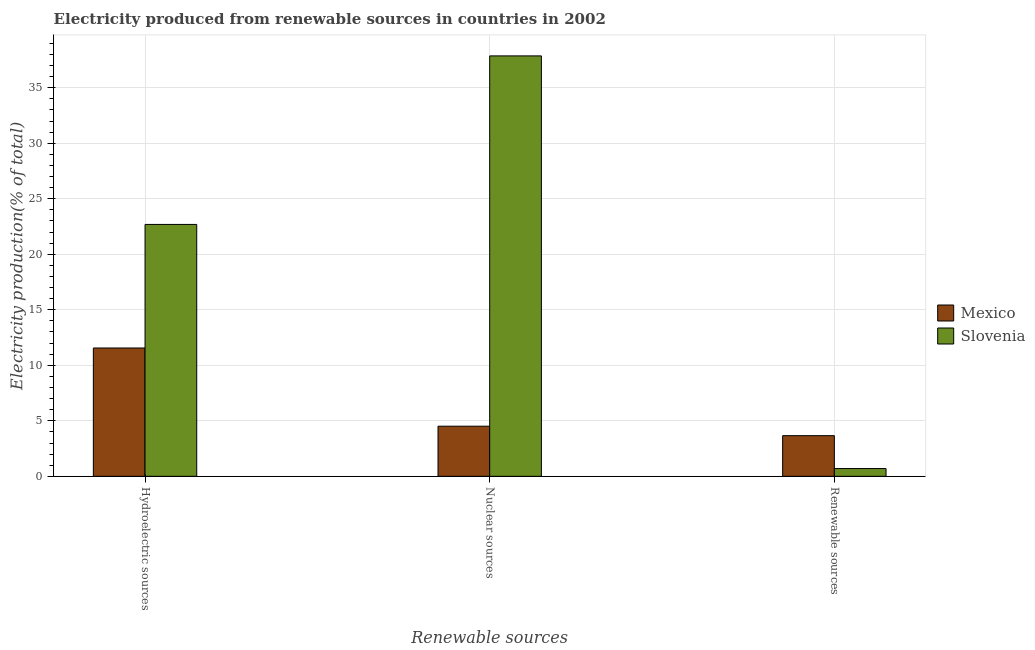How many different coloured bars are there?
Keep it short and to the point. 2. Are the number of bars on each tick of the X-axis equal?
Your response must be concise. Yes. What is the label of the 2nd group of bars from the left?
Your response must be concise. Nuclear sources. What is the percentage of electricity produced by nuclear sources in Slovenia?
Give a very brief answer. 37.87. Across all countries, what is the maximum percentage of electricity produced by nuclear sources?
Give a very brief answer. 37.87. Across all countries, what is the minimum percentage of electricity produced by renewable sources?
Give a very brief answer. 0.7. In which country was the percentage of electricity produced by hydroelectric sources maximum?
Keep it short and to the point. Slovenia. What is the total percentage of electricity produced by hydroelectric sources in the graph?
Provide a short and direct response. 34.25. What is the difference between the percentage of electricity produced by hydroelectric sources in Mexico and that in Slovenia?
Make the answer very short. -11.13. What is the difference between the percentage of electricity produced by renewable sources in Slovenia and the percentage of electricity produced by nuclear sources in Mexico?
Provide a succinct answer. -3.82. What is the average percentage of electricity produced by nuclear sources per country?
Your response must be concise. 21.19. What is the difference between the percentage of electricity produced by renewable sources and percentage of electricity produced by nuclear sources in Mexico?
Your answer should be very brief. -0.85. In how many countries, is the percentage of electricity produced by nuclear sources greater than 6 %?
Offer a terse response. 1. What is the ratio of the percentage of electricity produced by hydroelectric sources in Mexico to that in Slovenia?
Offer a terse response. 0.51. Is the difference between the percentage of electricity produced by hydroelectric sources in Slovenia and Mexico greater than the difference between the percentage of electricity produced by nuclear sources in Slovenia and Mexico?
Ensure brevity in your answer.  No. What is the difference between the highest and the second highest percentage of electricity produced by renewable sources?
Your answer should be compact. 2.96. What is the difference between the highest and the lowest percentage of electricity produced by nuclear sources?
Offer a terse response. 33.35. Is the sum of the percentage of electricity produced by hydroelectric sources in Mexico and Slovenia greater than the maximum percentage of electricity produced by nuclear sources across all countries?
Your answer should be compact. No. What does the 2nd bar from the left in Nuclear sources represents?
Provide a short and direct response. Slovenia. What does the 2nd bar from the right in Nuclear sources represents?
Provide a succinct answer. Mexico. Is it the case that in every country, the sum of the percentage of electricity produced by hydroelectric sources and percentage of electricity produced by nuclear sources is greater than the percentage of electricity produced by renewable sources?
Make the answer very short. Yes. How many bars are there?
Ensure brevity in your answer.  6. Are all the bars in the graph horizontal?
Your response must be concise. No. How many countries are there in the graph?
Offer a very short reply. 2. Are the values on the major ticks of Y-axis written in scientific E-notation?
Your answer should be compact. No. Does the graph contain any zero values?
Make the answer very short. No. How many legend labels are there?
Ensure brevity in your answer.  2. What is the title of the graph?
Keep it short and to the point. Electricity produced from renewable sources in countries in 2002. Does "Cuba" appear as one of the legend labels in the graph?
Your answer should be very brief. No. What is the label or title of the X-axis?
Ensure brevity in your answer.  Renewable sources. What is the Electricity production(% of total) in Mexico in Hydroelectric sources?
Ensure brevity in your answer.  11.56. What is the Electricity production(% of total) of Slovenia in Hydroelectric sources?
Your answer should be compact. 22.69. What is the Electricity production(% of total) of Mexico in Nuclear sources?
Provide a short and direct response. 4.52. What is the Electricity production(% of total) of Slovenia in Nuclear sources?
Provide a succinct answer. 37.87. What is the Electricity production(% of total) in Mexico in Renewable sources?
Provide a short and direct response. 3.66. What is the Electricity production(% of total) of Slovenia in Renewable sources?
Provide a succinct answer. 0.7. Across all Renewable sources, what is the maximum Electricity production(% of total) of Mexico?
Provide a succinct answer. 11.56. Across all Renewable sources, what is the maximum Electricity production(% of total) in Slovenia?
Your answer should be very brief. 37.87. Across all Renewable sources, what is the minimum Electricity production(% of total) of Mexico?
Offer a very short reply. 3.66. Across all Renewable sources, what is the minimum Electricity production(% of total) in Slovenia?
Keep it short and to the point. 0.7. What is the total Electricity production(% of total) of Mexico in the graph?
Keep it short and to the point. 19.73. What is the total Electricity production(% of total) of Slovenia in the graph?
Provide a succinct answer. 61.26. What is the difference between the Electricity production(% of total) of Mexico in Hydroelectric sources and that in Nuclear sources?
Your answer should be very brief. 7.04. What is the difference between the Electricity production(% of total) in Slovenia in Hydroelectric sources and that in Nuclear sources?
Offer a very short reply. -15.18. What is the difference between the Electricity production(% of total) of Mexico in Hydroelectric sources and that in Renewable sources?
Your answer should be compact. 7.9. What is the difference between the Electricity production(% of total) in Slovenia in Hydroelectric sources and that in Renewable sources?
Give a very brief answer. 21.99. What is the difference between the Electricity production(% of total) of Mexico in Nuclear sources and that in Renewable sources?
Offer a terse response. 0.85. What is the difference between the Electricity production(% of total) in Slovenia in Nuclear sources and that in Renewable sources?
Your answer should be compact. 37.17. What is the difference between the Electricity production(% of total) of Mexico in Hydroelectric sources and the Electricity production(% of total) of Slovenia in Nuclear sources?
Provide a short and direct response. -26.31. What is the difference between the Electricity production(% of total) in Mexico in Hydroelectric sources and the Electricity production(% of total) in Slovenia in Renewable sources?
Ensure brevity in your answer.  10.86. What is the difference between the Electricity production(% of total) of Mexico in Nuclear sources and the Electricity production(% of total) of Slovenia in Renewable sources?
Give a very brief answer. 3.82. What is the average Electricity production(% of total) in Mexico per Renewable sources?
Make the answer very short. 6.58. What is the average Electricity production(% of total) in Slovenia per Renewable sources?
Give a very brief answer. 20.42. What is the difference between the Electricity production(% of total) of Mexico and Electricity production(% of total) of Slovenia in Hydroelectric sources?
Keep it short and to the point. -11.13. What is the difference between the Electricity production(% of total) of Mexico and Electricity production(% of total) of Slovenia in Nuclear sources?
Keep it short and to the point. -33.35. What is the difference between the Electricity production(% of total) of Mexico and Electricity production(% of total) of Slovenia in Renewable sources?
Make the answer very short. 2.96. What is the ratio of the Electricity production(% of total) of Mexico in Hydroelectric sources to that in Nuclear sources?
Provide a succinct answer. 2.56. What is the ratio of the Electricity production(% of total) of Slovenia in Hydroelectric sources to that in Nuclear sources?
Your answer should be very brief. 0.6. What is the ratio of the Electricity production(% of total) in Mexico in Hydroelectric sources to that in Renewable sources?
Offer a terse response. 3.16. What is the ratio of the Electricity production(% of total) of Slovenia in Hydroelectric sources to that in Renewable sources?
Your answer should be very brief. 32.47. What is the ratio of the Electricity production(% of total) of Mexico in Nuclear sources to that in Renewable sources?
Your response must be concise. 1.23. What is the ratio of the Electricity production(% of total) in Slovenia in Nuclear sources to that in Renewable sources?
Your answer should be very brief. 54.2. What is the difference between the highest and the second highest Electricity production(% of total) of Mexico?
Make the answer very short. 7.04. What is the difference between the highest and the second highest Electricity production(% of total) of Slovenia?
Give a very brief answer. 15.18. What is the difference between the highest and the lowest Electricity production(% of total) in Mexico?
Keep it short and to the point. 7.9. What is the difference between the highest and the lowest Electricity production(% of total) in Slovenia?
Make the answer very short. 37.17. 